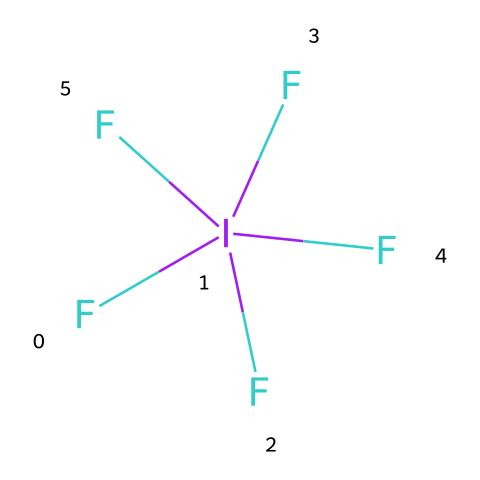What is the molecular formula of iodine pentafluoride? The chemical structure indicates one iodine atom and five fluorine atoms, leading to the molecular formula IF5.
Answer: IF5 How many fluorine atoms are present in this molecule? The structure clearly shows five fluorine atoms bonded to one iodine atom.
Answer: 5 Is iodine pentafluoride a hypervalent compound? Iodine in this molecule exceeds the typical octet rule, as it is surrounded by five fluorine atoms, which confirms it as a hypervalent compound.
Answer: Yes What is the oxidation state of iodine in iodine pentafluoride? In IF5, iodine is the central atom and has an oxidation state of +5, calculated by considering the -1 charge from each fluorine atom.
Answer: +5 Which type of bonding primarily occurs between the iodine and fluorine atoms? The bonds formed between iodine and fluorine in IF5 are primarily covalent bonds, due to the sharing of electrons.
Answer: Covalent How does iodine pentafluoride act as an oxidizing agent? The presence of highly electronegative fluorine atoms allows the compound to readily accept electrons, thereby facilitating oxidation reactions.
Answer: Accepts electrons What unique property does the hypervalency of iodine pentafluoride impart? The hypervalency allows iodine pentafluoride to react with a wider range of substances due to its ability to expand its bonding capacity for reactions.
Answer: Reactivity 